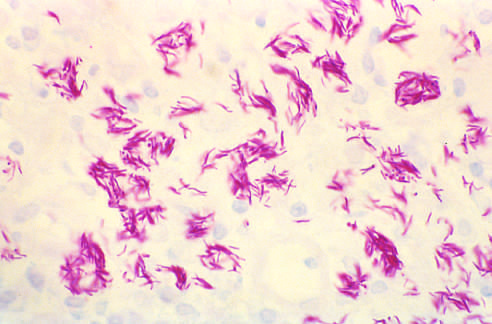what is aids?
Answer the question using a single word or phrase. Acquired immunodeficiency syndrome 